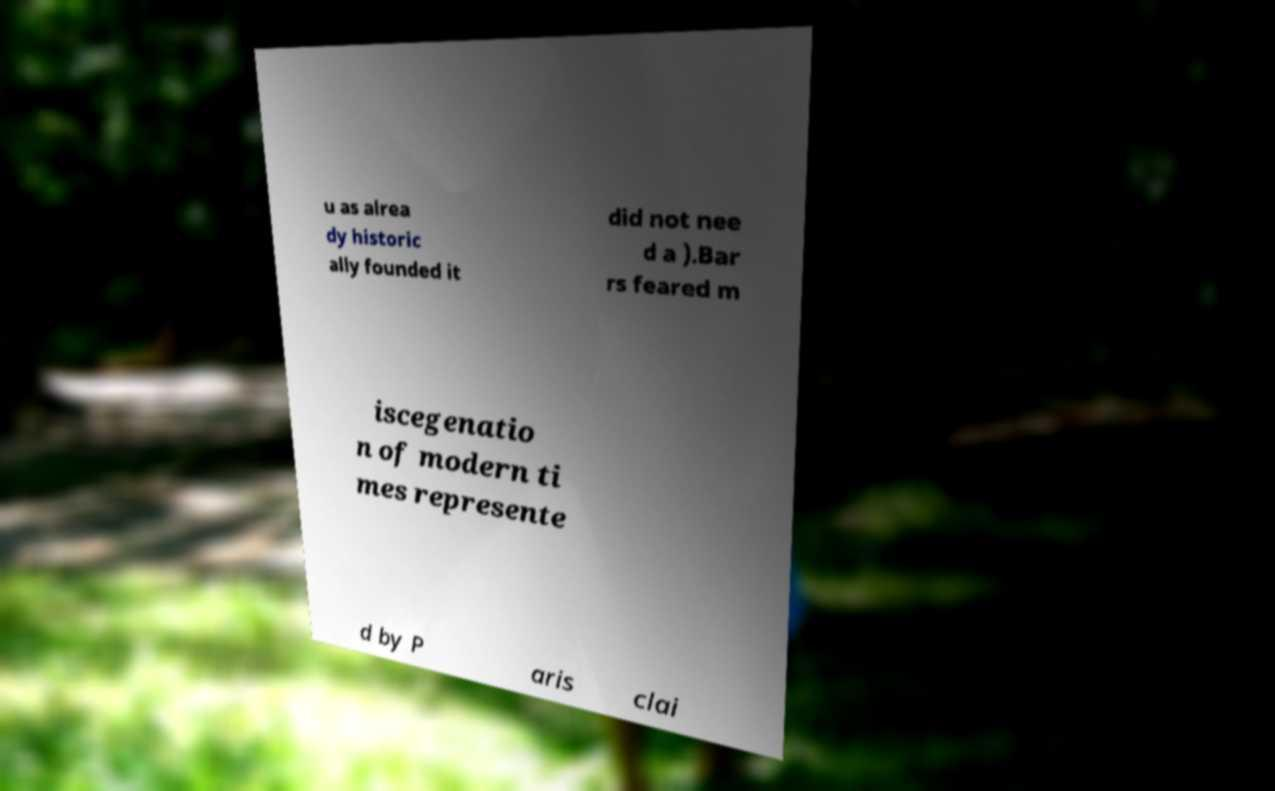What messages or text are displayed in this image? I need them in a readable, typed format. u as alrea dy historic ally founded it did not nee d a ).Bar rs feared m iscegenatio n of modern ti mes represente d by P aris clai 